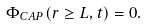<formula> <loc_0><loc_0><loc_500><loc_500>\Phi _ { C A P } ( r \geq L , t ) = 0 .</formula> 